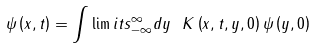Convert formula to latex. <formula><loc_0><loc_0><loc_500><loc_500>\psi \left ( x , t \right ) = \int \lim i t s _ { - \infty } ^ { \infty } d y \text { } K \left ( x , t , y , 0 \right ) \psi \left ( y , 0 \right )</formula> 